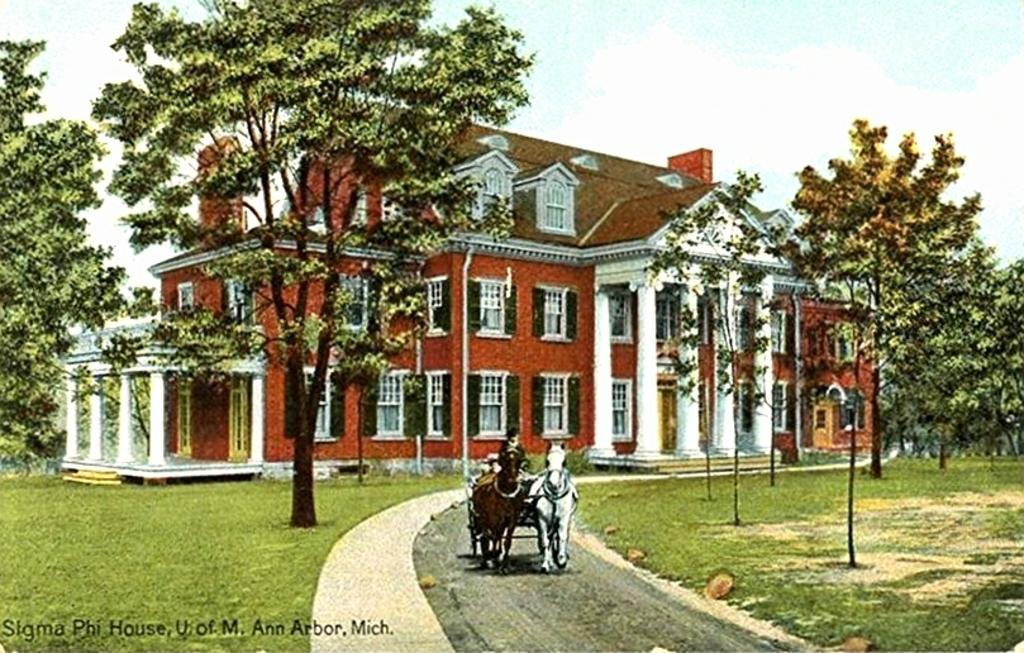What is the person in the image doing? The person is sitting on a horse cart in the image. What structure can be seen in the background of the image? There is a house in the image. What type of vegetation is present around the house? Trees are present around the house. What is the ground covered with in the image? There is grass on the ground in the image. What type of pipe is being used by the person sitting on the horse cart in the image? There is no pipe present in the image; the person is sitting on a horse cart. How many beans can be seen on the ground in the image? There are no beans visible on the ground in the image; it is covered with grass. 